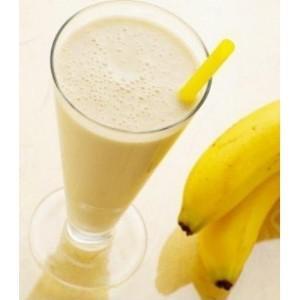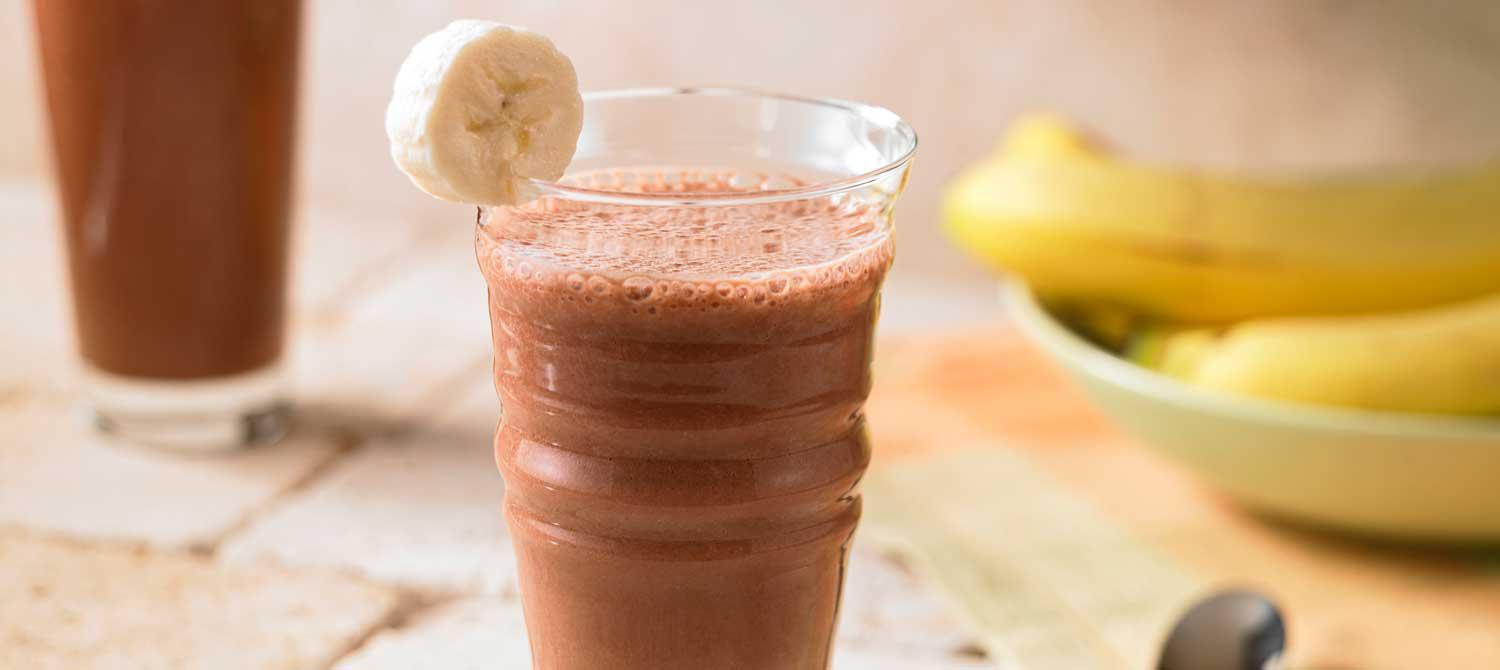The first image is the image on the left, the second image is the image on the right. Examine the images to the left and right. Is the description "there is a glass with at least one straw in it" accurate? Answer yes or no. Yes. The first image is the image on the left, the second image is the image on the right. Assess this claim about the two images: "All images include unpeeled bananas, and one image includes a brown drink garnished with a slice of banana, while the other image includes a glass with something bright yellow sticking out of the top.". Correct or not? Answer yes or no. Yes. 